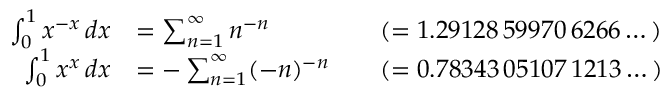Convert formula to latex. <formula><loc_0><loc_0><loc_500><loc_500>{ \begin{array} { r l r l } { \int _ { 0 } ^ { 1 } x ^ { - x } \, d x } & { = \sum _ { n = 1 } ^ { \infty } n ^ { - n } } & & { ( = 1 . 2 9 1 2 8 \, 5 9 9 7 0 \, 6 2 6 6 \dots ) } \\ { \int _ { 0 } ^ { 1 } x ^ { x } \, d x } & { = - \sum _ { n = 1 } ^ { \infty } ( - n ) ^ { - n } } & & { ( = 0 . 7 8 3 4 3 \, 0 5 1 0 7 \, 1 2 1 3 \dots ) } \end{array} }</formula> 